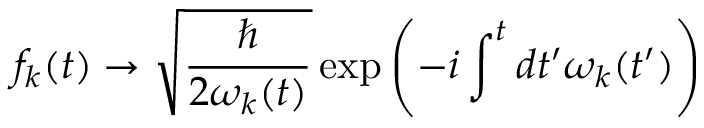Convert formula to latex. <formula><loc_0><loc_0><loc_500><loc_500>f _ { k } ( t ) \rightarrow { \sqrt { \frac { } { 2 \omega _ { k } ( t ) } } } \exp \left ( - i \int ^ { t } d t ^ { \prime } \omega _ { k } ( t ^ { \prime } ) \right )</formula> 